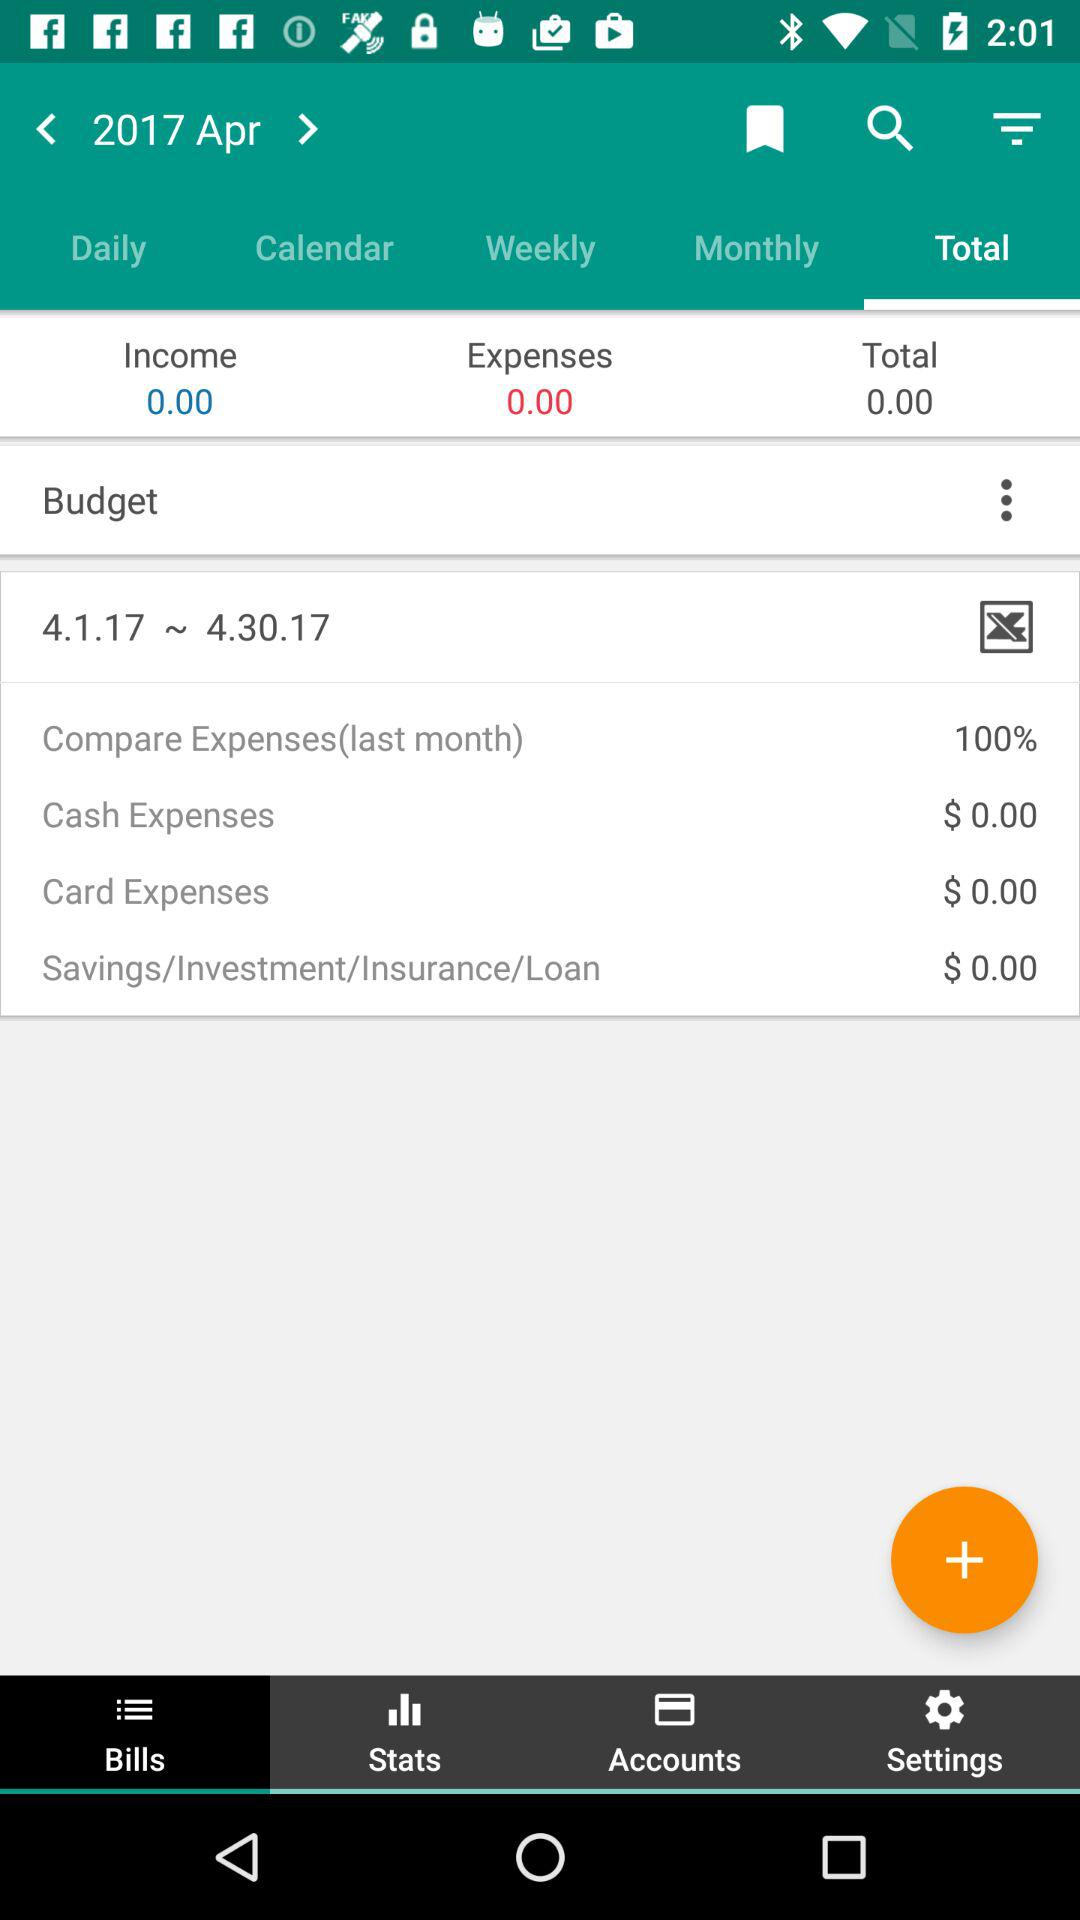What is the selected year and month? The selected year and month are 2017 and April, respectively. 